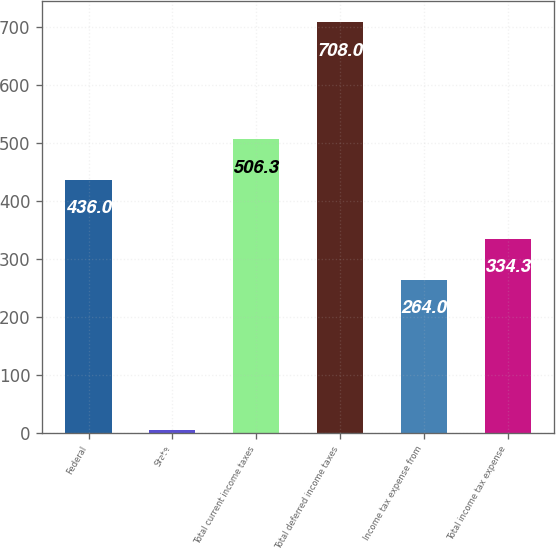Convert chart. <chart><loc_0><loc_0><loc_500><loc_500><bar_chart><fcel>Federal<fcel>State<fcel>Total current income taxes<fcel>Total deferred income taxes<fcel>Income tax expense from<fcel>Total income tax expense<nl><fcel>436<fcel>5<fcel>506.3<fcel>708<fcel>264<fcel>334.3<nl></chart> 